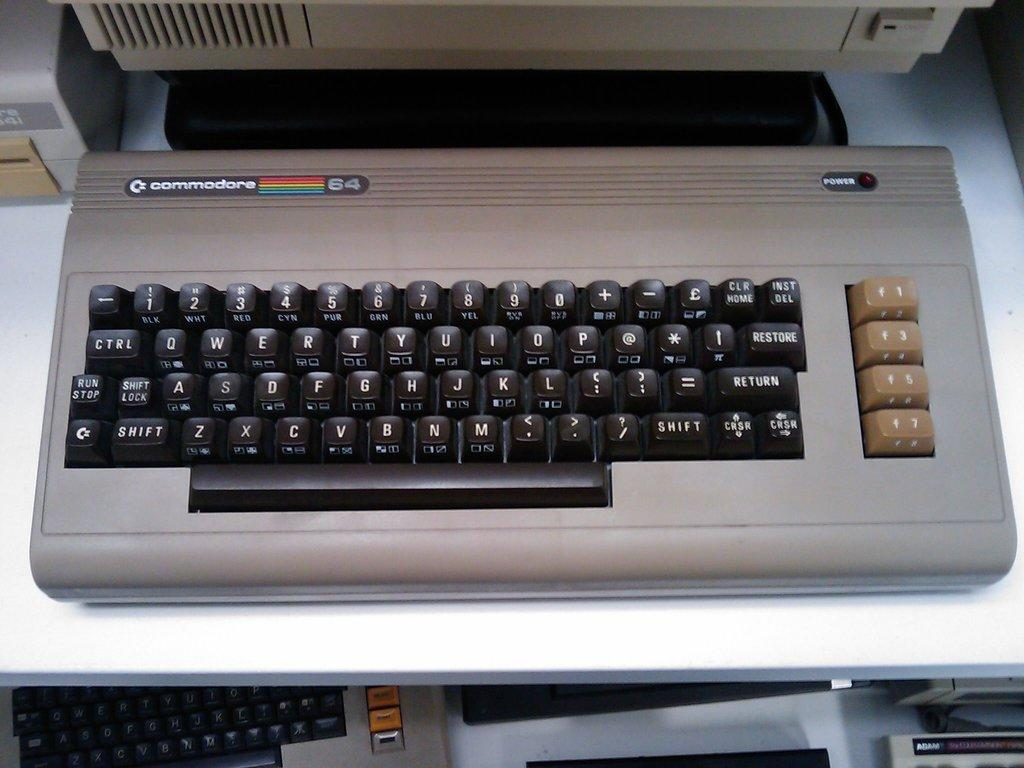<image>
Relay a brief, clear account of the picture shown. A Commodore 64 keyboard along with a monitor rest on a desk. 